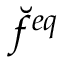Convert formula to latex. <formula><loc_0><loc_0><loc_500><loc_500>\breve { f } ^ { e q }</formula> 